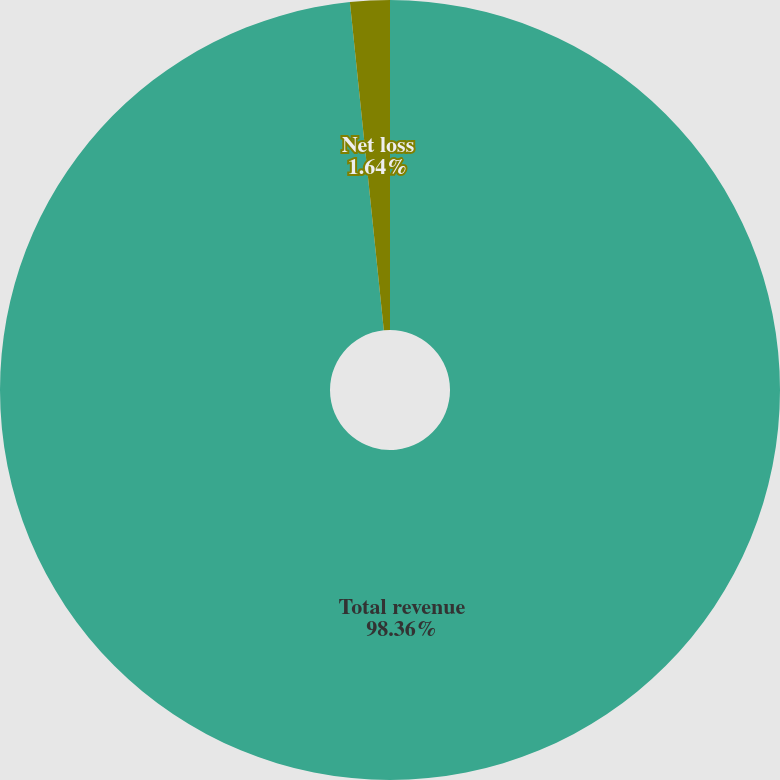Convert chart to OTSL. <chart><loc_0><loc_0><loc_500><loc_500><pie_chart><fcel>Total revenue<fcel>Net loss<nl><fcel>98.36%<fcel>1.64%<nl></chart> 